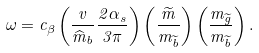<formula> <loc_0><loc_0><loc_500><loc_500>\omega = c _ { \beta } \left ( \frac { v } { \widehat { m } _ { b } } \frac { 2 \alpha _ { s } } { 3 \pi } \right ) \left ( \frac { \widetilde { m } } { m _ { \widetilde { b } } } \right ) \left ( \frac { m _ { \widetilde { g } } } { m _ { \widetilde { b } } } \right ) .</formula> 